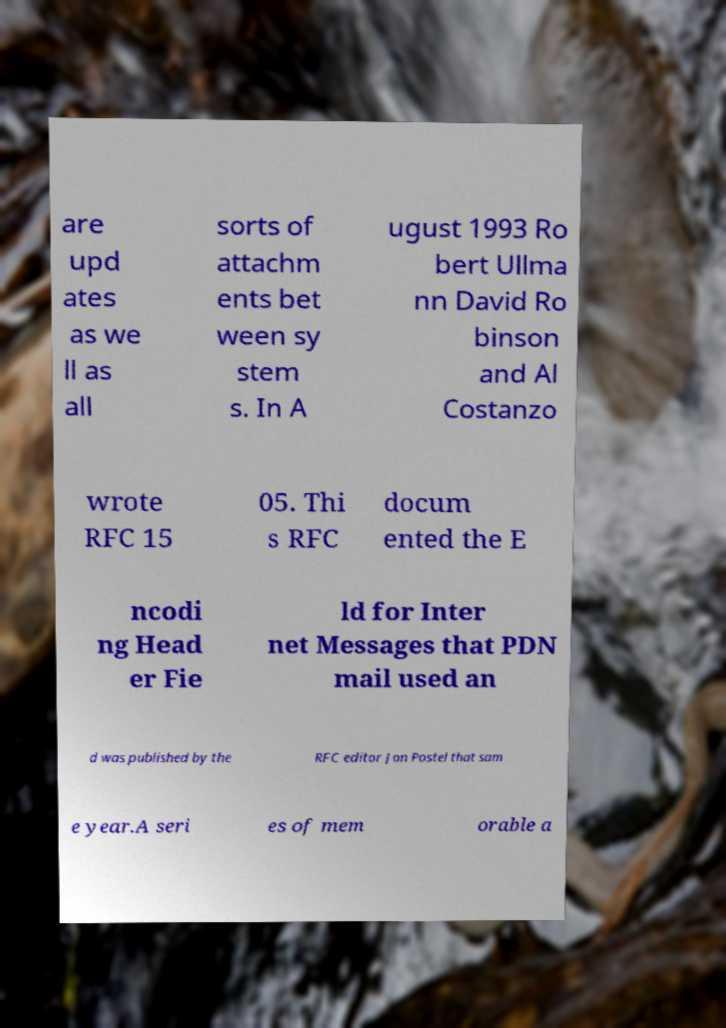I need the written content from this picture converted into text. Can you do that? are upd ates as we ll as all sorts of attachm ents bet ween sy stem s. In A ugust 1993 Ro bert Ullma nn David Ro binson and Al Costanzo wrote RFC 15 05. Thi s RFC docum ented the E ncodi ng Head er Fie ld for Inter net Messages that PDN mail used an d was published by the RFC editor Jon Postel that sam e year.A seri es of mem orable a 